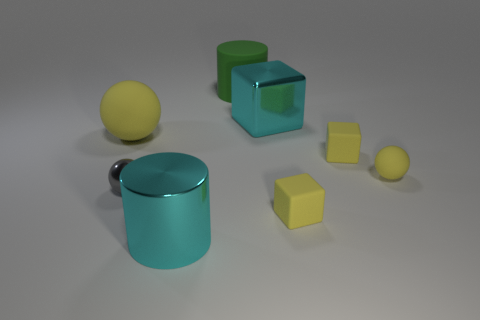Add 2 large matte things. How many objects exist? 10 Subtract all blocks. How many objects are left? 5 Add 5 gray shiny balls. How many gray shiny balls exist? 6 Subtract 0 brown cylinders. How many objects are left? 8 Subtract all tiny purple metallic cylinders. Subtract all large shiny blocks. How many objects are left? 7 Add 6 big green matte objects. How many big green matte objects are left? 7 